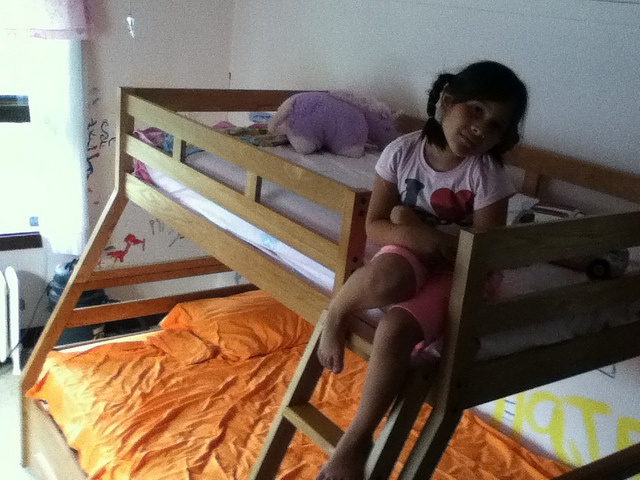Describe the objects in this image and their specific colors. I can see bed in ivory, brown, orange, red, and khaki tones, people in ivory, black, gray, and maroon tones, and bed in ivory, gray, darkgray, and tan tones in this image. 